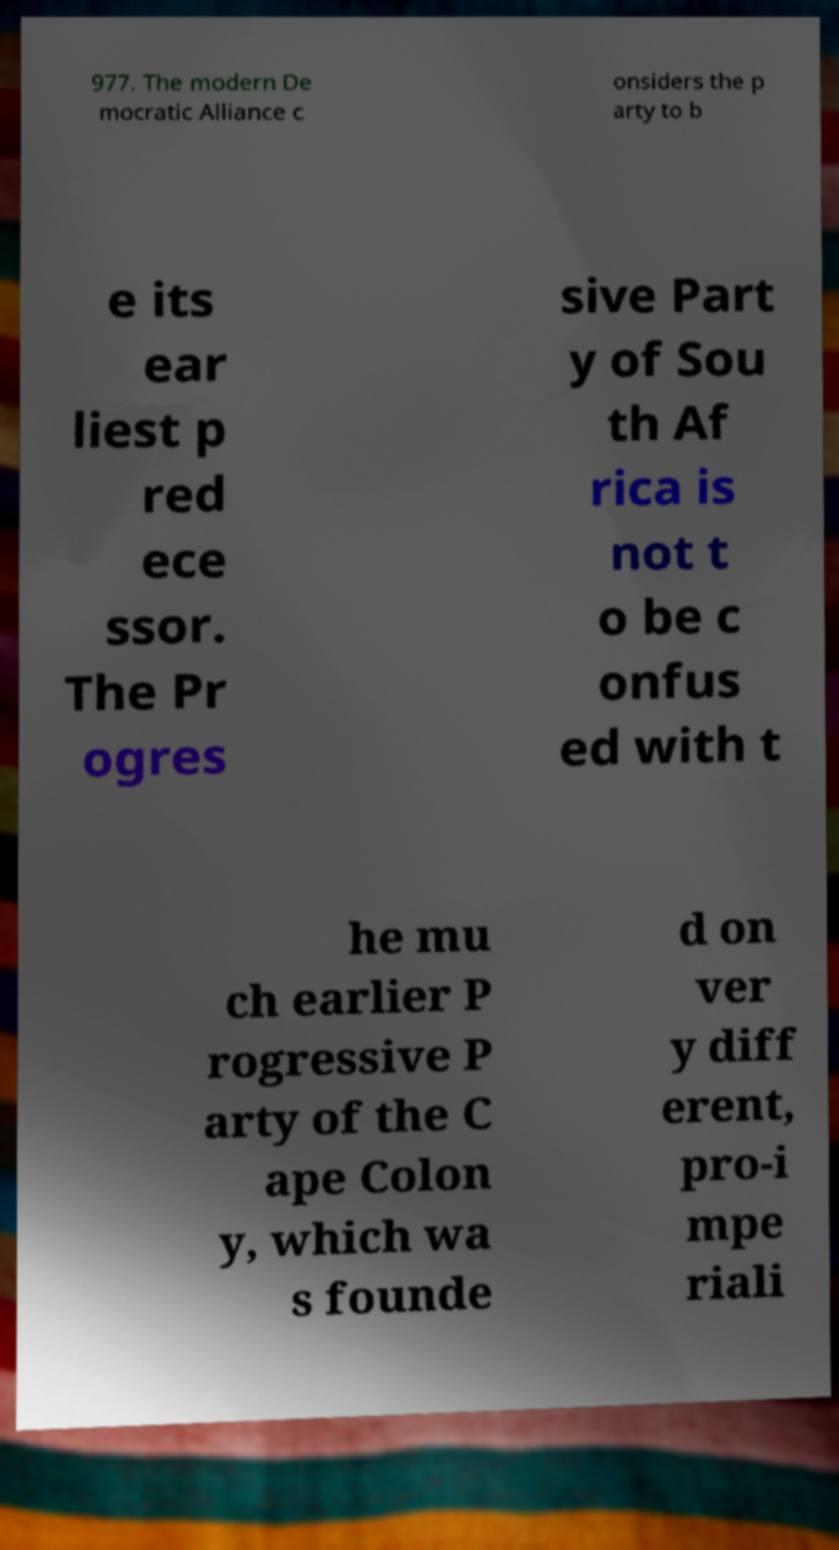Please identify and transcribe the text found in this image. 977. The modern De mocratic Alliance c onsiders the p arty to b e its ear liest p red ece ssor. The Pr ogres sive Part y of Sou th Af rica is not t o be c onfus ed with t he mu ch earlier P rogressive P arty of the C ape Colon y, which wa s founde d on ver y diff erent, pro-i mpe riali 